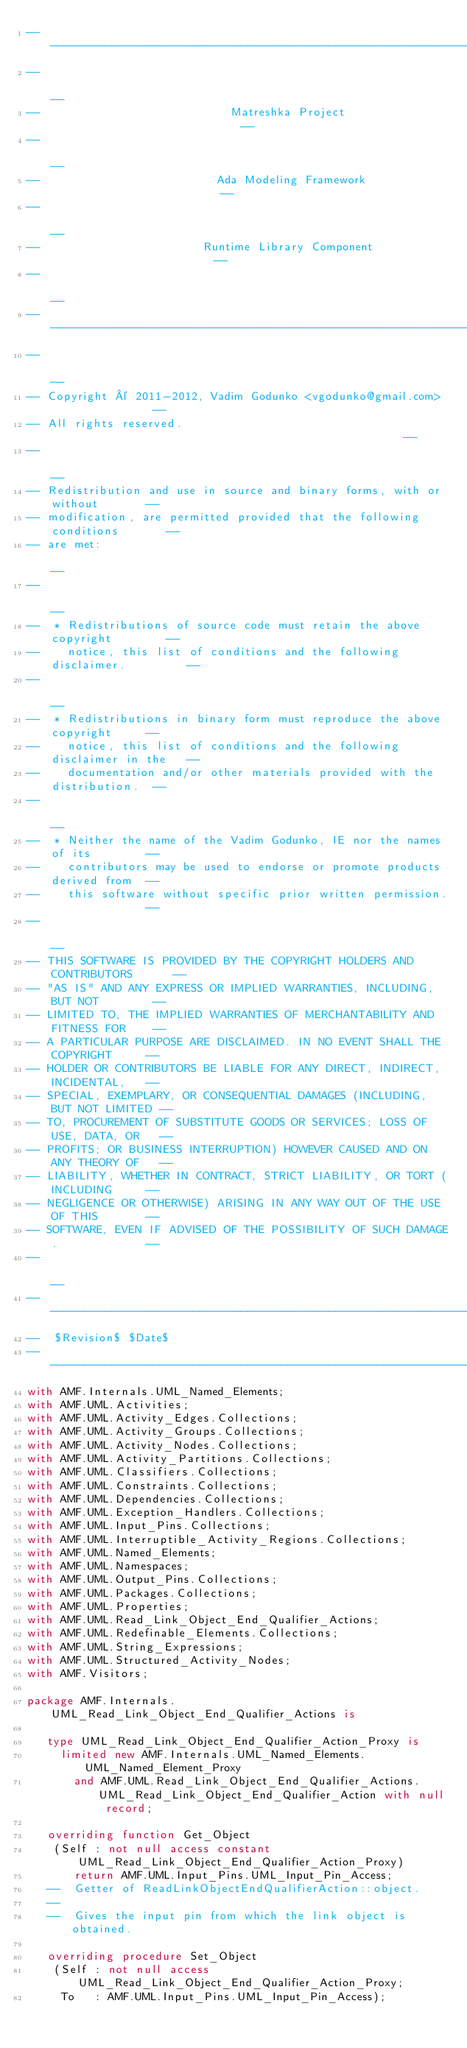Convert code to text. <code><loc_0><loc_0><loc_500><loc_500><_Ada_>------------------------------------------------------------------------------
--                                                                          --
--                            Matreshka Project                             --
--                                                                          --
--                          Ada Modeling Framework                          --
--                                                                          --
--                        Runtime Library Component                         --
--                                                                          --
------------------------------------------------------------------------------
--                                                                          --
-- Copyright © 2011-2012, Vadim Godunko <vgodunko@gmail.com>                --
-- All rights reserved.                                                     --
--                                                                          --
-- Redistribution and use in source and binary forms, with or without       --
-- modification, are permitted provided that the following conditions       --
-- are met:                                                                 --
--                                                                          --
--  * Redistributions of source code must retain the above copyright        --
--    notice, this list of conditions and the following disclaimer.         --
--                                                                          --
--  * Redistributions in binary form must reproduce the above copyright     --
--    notice, this list of conditions and the following disclaimer in the   --
--    documentation and/or other materials provided with the distribution.  --
--                                                                          --
--  * Neither the name of the Vadim Godunko, IE nor the names of its        --
--    contributors may be used to endorse or promote products derived from  --
--    this software without specific prior written permission.              --
--                                                                          --
-- THIS SOFTWARE IS PROVIDED BY THE COPYRIGHT HOLDERS AND CONTRIBUTORS      --
-- "AS IS" AND ANY EXPRESS OR IMPLIED WARRANTIES, INCLUDING, BUT NOT        --
-- LIMITED TO, THE IMPLIED WARRANTIES OF MERCHANTABILITY AND FITNESS FOR    --
-- A PARTICULAR PURPOSE ARE DISCLAIMED. IN NO EVENT SHALL THE COPYRIGHT     --
-- HOLDER OR CONTRIBUTORS BE LIABLE FOR ANY DIRECT, INDIRECT, INCIDENTAL,   --
-- SPECIAL, EXEMPLARY, OR CONSEQUENTIAL DAMAGES (INCLUDING, BUT NOT LIMITED --
-- TO, PROCUREMENT OF SUBSTITUTE GOODS OR SERVICES; LOSS OF USE, DATA, OR   --
-- PROFITS; OR BUSINESS INTERRUPTION) HOWEVER CAUSED AND ON ANY THEORY OF   --
-- LIABILITY, WHETHER IN CONTRACT, STRICT LIABILITY, OR TORT (INCLUDING     --
-- NEGLIGENCE OR OTHERWISE) ARISING IN ANY WAY OUT OF THE USE OF THIS       --
-- SOFTWARE, EVEN IF ADVISED OF THE POSSIBILITY OF SUCH DAMAGE.             --
--                                                                          --
------------------------------------------------------------------------------
--  $Revision$ $Date$
------------------------------------------------------------------------------
with AMF.Internals.UML_Named_Elements;
with AMF.UML.Activities;
with AMF.UML.Activity_Edges.Collections;
with AMF.UML.Activity_Groups.Collections;
with AMF.UML.Activity_Nodes.Collections;
with AMF.UML.Activity_Partitions.Collections;
with AMF.UML.Classifiers.Collections;
with AMF.UML.Constraints.Collections;
with AMF.UML.Dependencies.Collections;
with AMF.UML.Exception_Handlers.Collections;
with AMF.UML.Input_Pins.Collections;
with AMF.UML.Interruptible_Activity_Regions.Collections;
with AMF.UML.Named_Elements;
with AMF.UML.Namespaces;
with AMF.UML.Output_Pins.Collections;
with AMF.UML.Packages.Collections;
with AMF.UML.Properties;
with AMF.UML.Read_Link_Object_End_Qualifier_Actions;
with AMF.UML.Redefinable_Elements.Collections;
with AMF.UML.String_Expressions;
with AMF.UML.Structured_Activity_Nodes;
with AMF.Visitors;

package AMF.Internals.UML_Read_Link_Object_End_Qualifier_Actions is

   type UML_Read_Link_Object_End_Qualifier_Action_Proxy is
     limited new AMF.Internals.UML_Named_Elements.UML_Named_Element_Proxy
       and AMF.UML.Read_Link_Object_End_Qualifier_Actions.UML_Read_Link_Object_End_Qualifier_Action with null record;

   overriding function Get_Object
    (Self : not null access constant UML_Read_Link_Object_End_Qualifier_Action_Proxy)
       return AMF.UML.Input_Pins.UML_Input_Pin_Access;
   --  Getter of ReadLinkObjectEndQualifierAction::object.
   --
   --  Gives the input pin from which the link object is obtained.

   overriding procedure Set_Object
    (Self : not null access UML_Read_Link_Object_End_Qualifier_Action_Proxy;
     To   : AMF.UML.Input_Pins.UML_Input_Pin_Access);</code> 